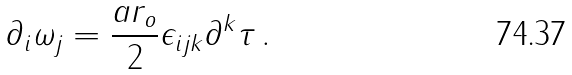Convert formula to latex. <formula><loc_0><loc_0><loc_500><loc_500>\partial _ { i } \omega _ { j } = \frac { a r _ { o } } 2 \epsilon _ { i j k } \partial ^ { k } \tau \, .</formula> 